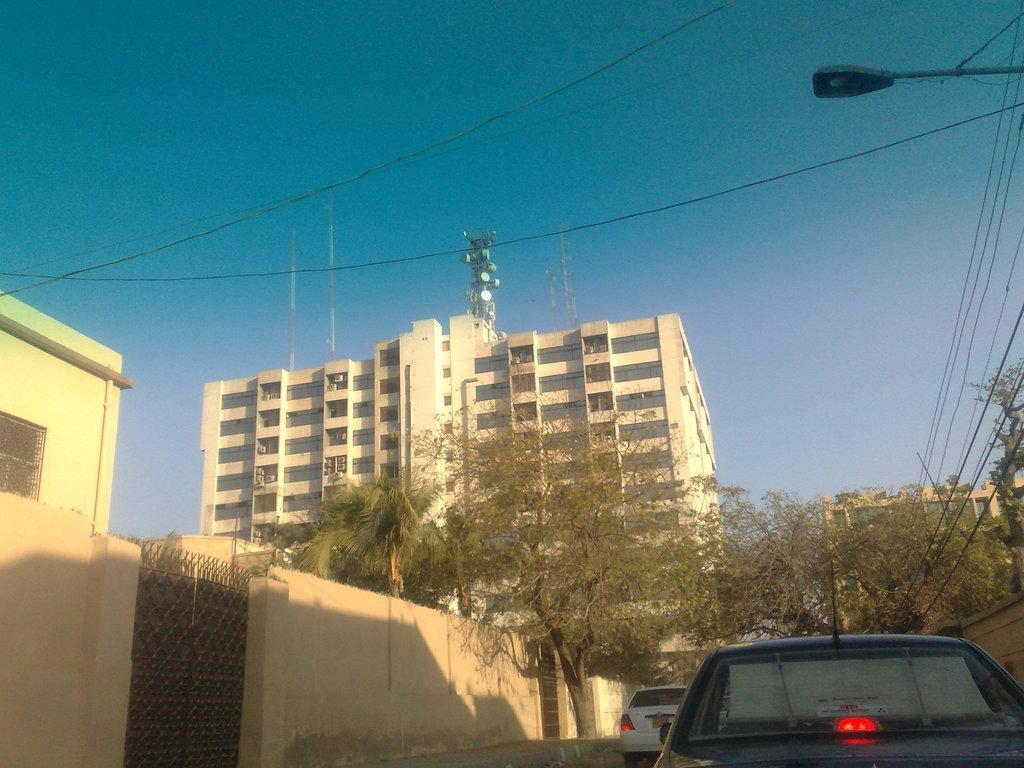How would you summarize this image in a sentence or two? In this image, we can see buildings, walls, trees, grills, wires and tower. At the bottom, we can see vehicles. Background we can see the sky. On the right side top of the image, we can see a street light. 